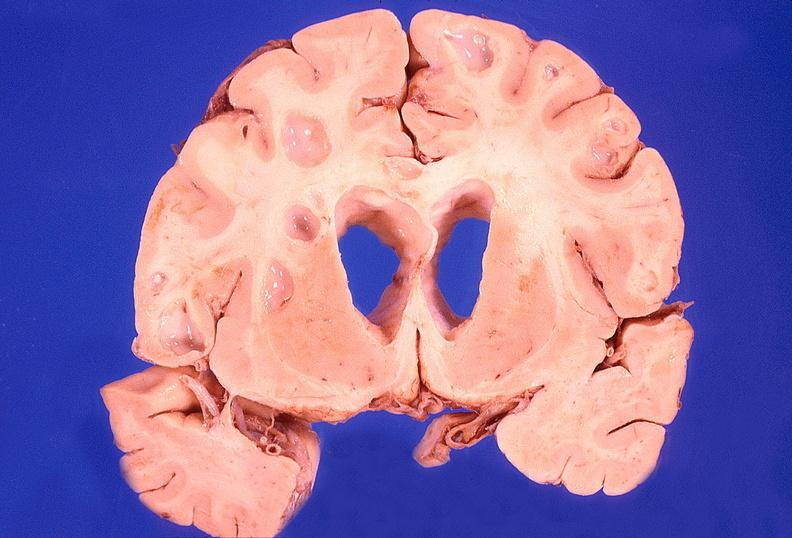what is present?
Answer the question using a single word or phrase. Nervous 